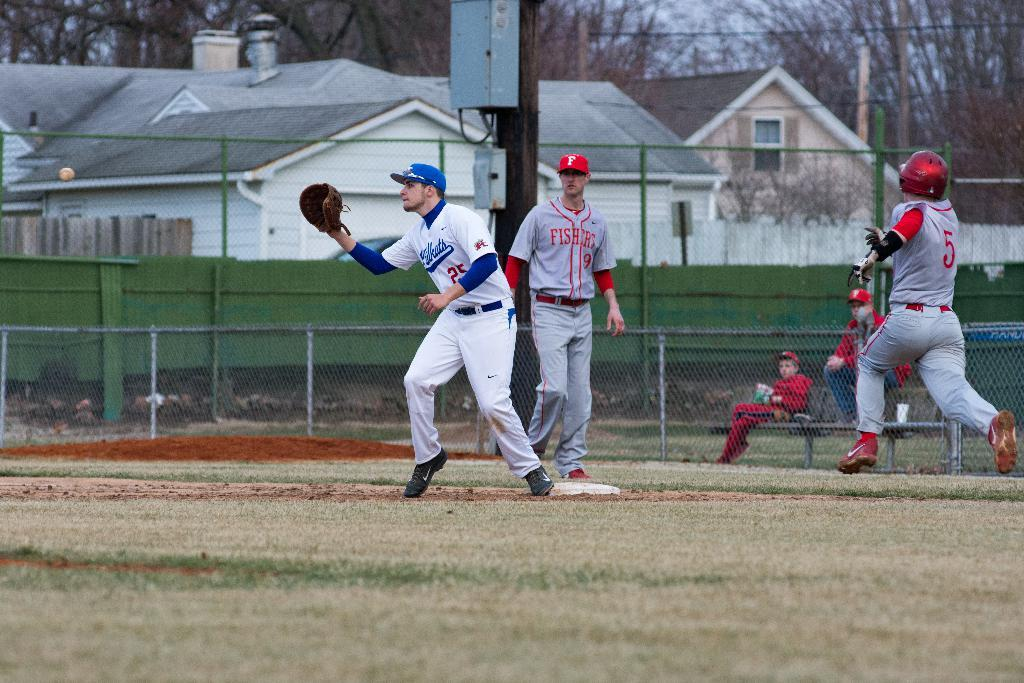Provide a one-sentence caption for the provided image. A baseball team is taking place where a player in a Fishers uniform runs to go to the base before he is out. 